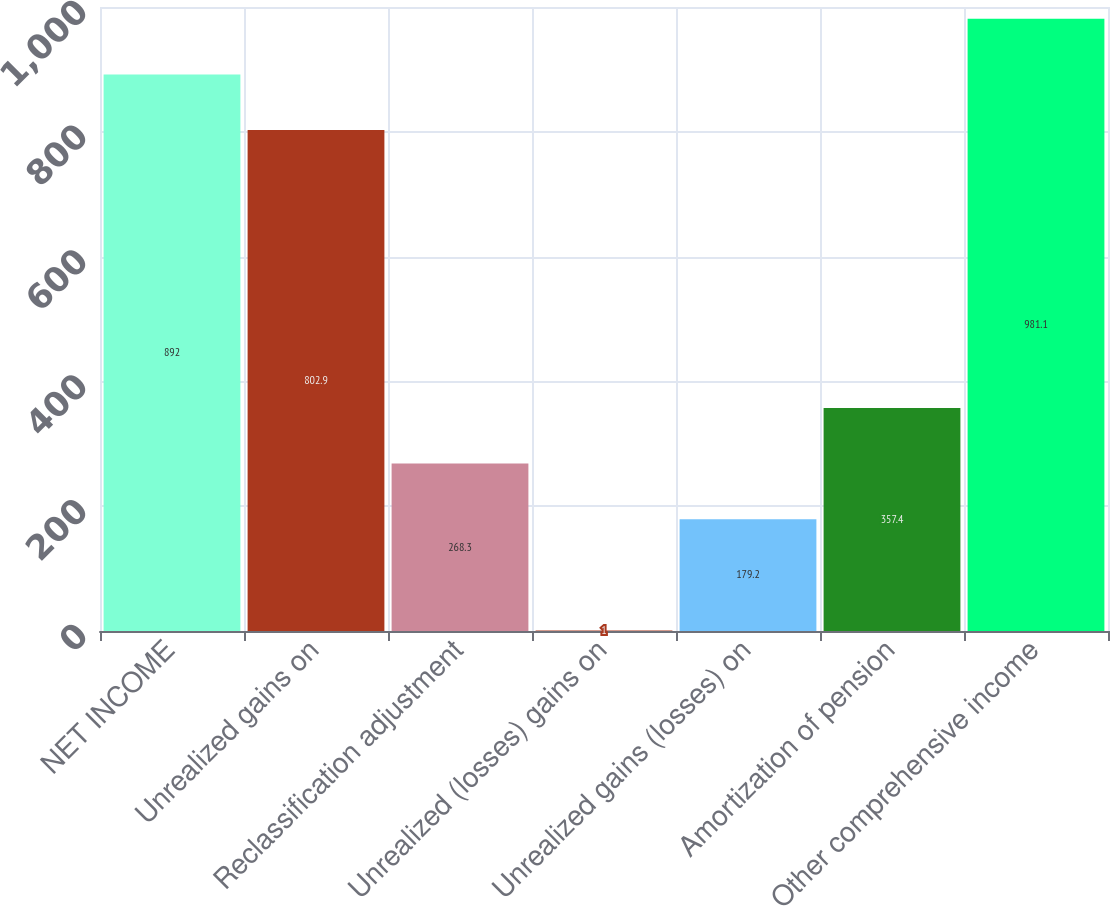<chart> <loc_0><loc_0><loc_500><loc_500><bar_chart><fcel>NET INCOME<fcel>Unrealized gains on<fcel>Reclassification adjustment<fcel>Unrealized (losses) gains on<fcel>Unrealized gains (losses) on<fcel>Amortization of pension<fcel>Other comprehensive income<nl><fcel>892<fcel>802.9<fcel>268.3<fcel>1<fcel>179.2<fcel>357.4<fcel>981.1<nl></chart> 